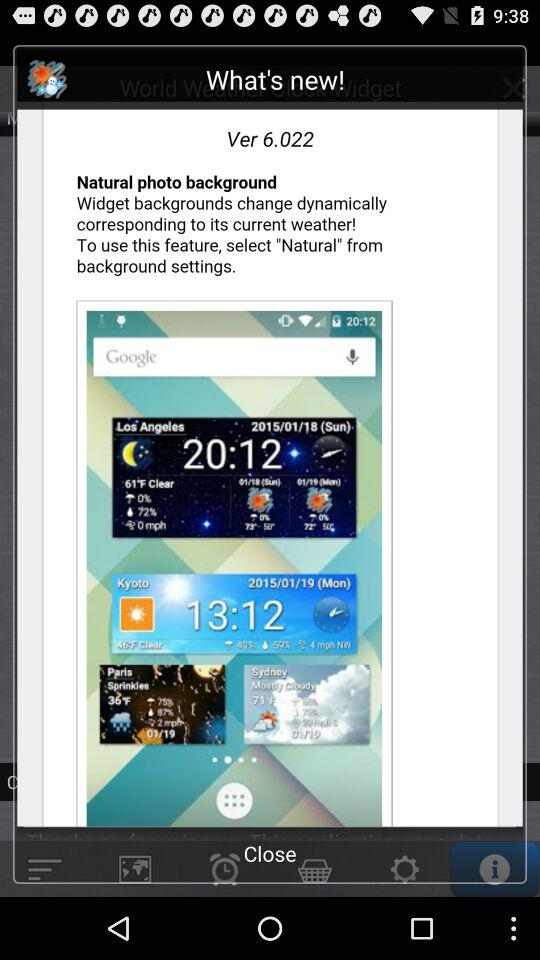How do I enable the feature of widget backgrounds changing dynamically based on the weather?
When the provided information is insufficient, respond with <no answer>. <no answer> 